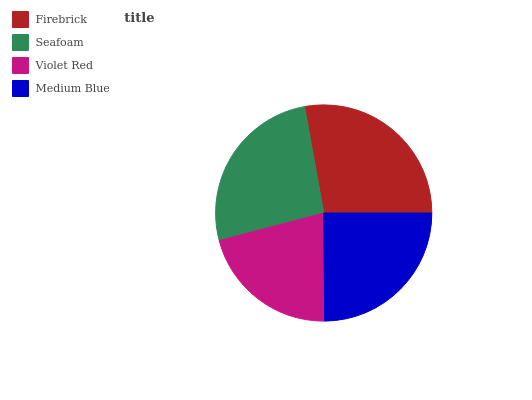Is Violet Red the minimum?
Answer yes or no. Yes. Is Firebrick the maximum?
Answer yes or no. Yes. Is Seafoam the minimum?
Answer yes or no. No. Is Seafoam the maximum?
Answer yes or no. No. Is Firebrick greater than Seafoam?
Answer yes or no. Yes. Is Seafoam less than Firebrick?
Answer yes or no. Yes. Is Seafoam greater than Firebrick?
Answer yes or no. No. Is Firebrick less than Seafoam?
Answer yes or no. No. Is Seafoam the high median?
Answer yes or no. Yes. Is Medium Blue the low median?
Answer yes or no. Yes. Is Firebrick the high median?
Answer yes or no. No. Is Seafoam the low median?
Answer yes or no. No. 